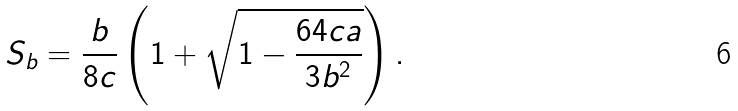<formula> <loc_0><loc_0><loc_500><loc_500>S _ { b } = \frac { b } { 8 c } \left ( 1 + \sqrt { 1 - \frac { 6 4 c a } { 3 b ^ { 2 } } } \right ) .</formula> 